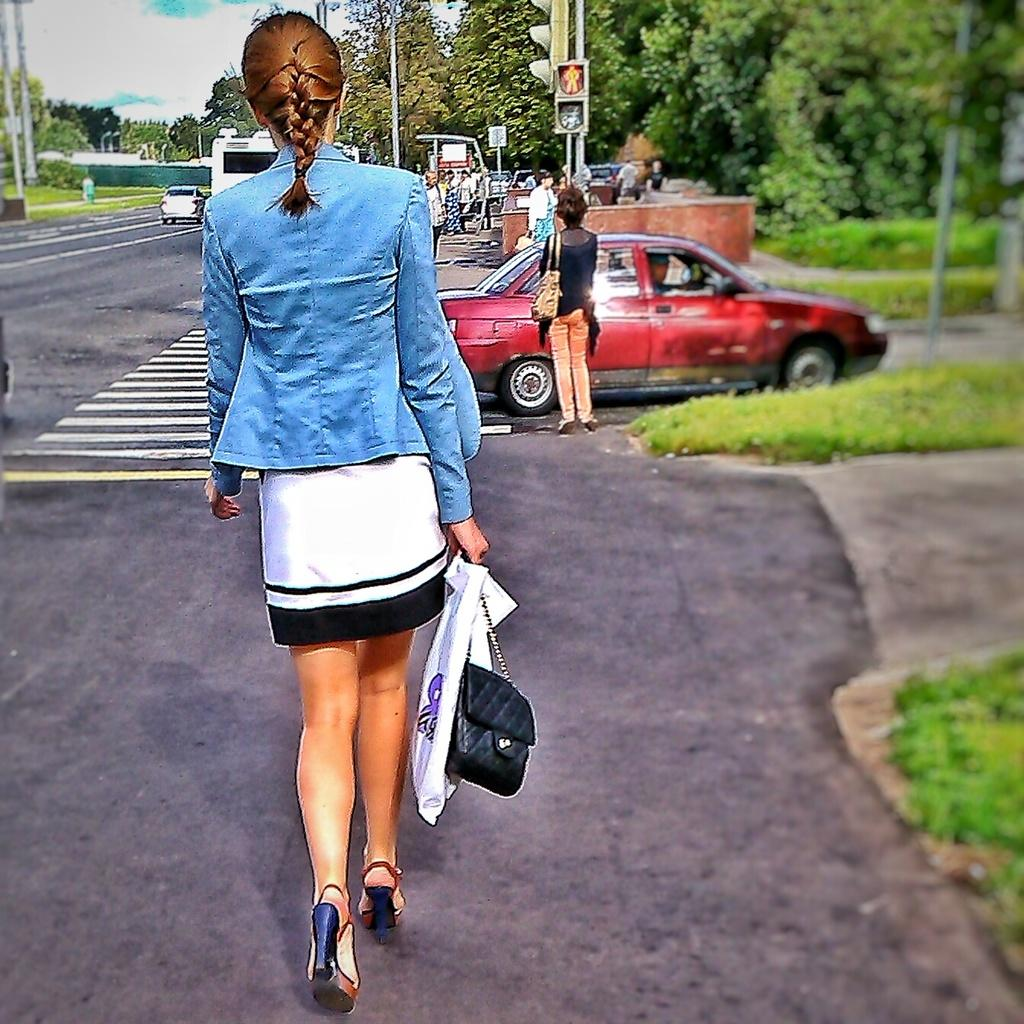What is the woman in the image doing? The woman is walking on the road. What else is happening on the road? A car is moving on the road. Can you describe the car's color? The car is dark red in color. What is present on the road to regulate traffic? There is a signal on the road. What can be seen on the right side of the road? There are trees on the right side of the road. Can you tell me how many dolls are sitting on the jellyfish in the image? There are no dolls or jellyfish present in the image; it features a woman walking on the road and a car moving on the road. 